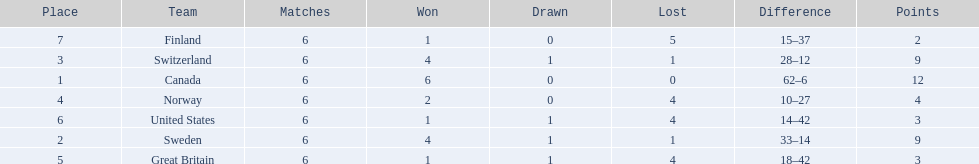What are all the teams? Canada, Sweden, Switzerland, Norway, Great Britain, United States, Finland. What were their points? 12, 9, 9, 4, 3, 3, 2. What about just switzerland and great britain? 9, 3. Now, which of those teams scored higher? Switzerland. 